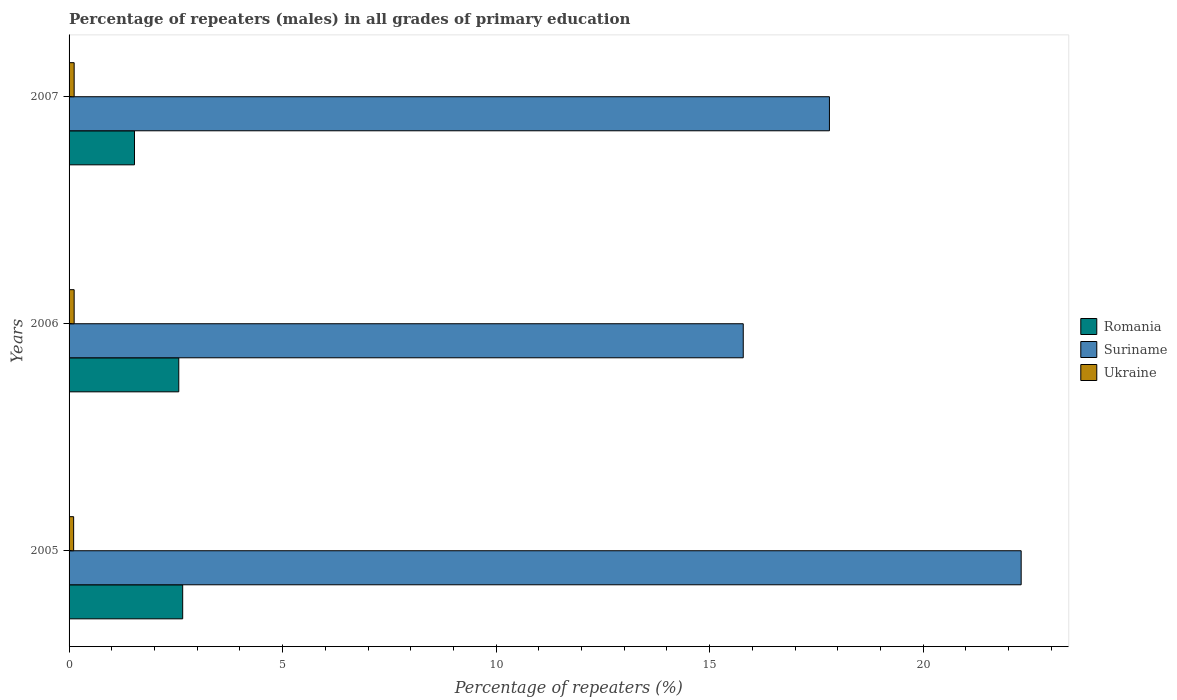How many different coloured bars are there?
Your answer should be very brief. 3. How many groups of bars are there?
Provide a succinct answer. 3. How many bars are there on the 2nd tick from the top?
Offer a terse response. 3. What is the percentage of repeaters (males) in Romania in 2007?
Offer a terse response. 1.53. Across all years, what is the maximum percentage of repeaters (males) in Ukraine?
Give a very brief answer. 0.12. Across all years, what is the minimum percentage of repeaters (males) in Ukraine?
Ensure brevity in your answer.  0.11. In which year was the percentage of repeaters (males) in Romania maximum?
Offer a very short reply. 2005. What is the total percentage of repeaters (males) in Romania in the graph?
Provide a short and direct response. 6.76. What is the difference between the percentage of repeaters (males) in Romania in 2005 and that in 2007?
Ensure brevity in your answer.  1.13. What is the difference between the percentage of repeaters (males) in Romania in 2006 and the percentage of repeaters (males) in Suriname in 2007?
Give a very brief answer. -15.24. What is the average percentage of repeaters (males) in Suriname per year?
Offer a terse response. 18.63. In the year 2005, what is the difference between the percentage of repeaters (males) in Romania and percentage of repeaters (males) in Ukraine?
Your answer should be very brief. 2.55. What is the ratio of the percentage of repeaters (males) in Suriname in 2006 to that in 2007?
Make the answer very short. 0.89. Is the percentage of repeaters (males) in Romania in 2005 less than that in 2006?
Offer a very short reply. No. What is the difference between the highest and the second highest percentage of repeaters (males) in Ukraine?
Keep it short and to the point. 0. What is the difference between the highest and the lowest percentage of repeaters (males) in Ukraine?
Your answer should be very brief. 0.01. In how many years, is the percentage of repeaters (males) in Suriname greater than the average percentage of repeaters (males) in Suriname taken over all years?
Offer a very short reply. 1. Is the sum of the percentage of repeaters (males) in Ukraine in 2005 and 2007 greater than the maximum percentage of repeaters (males) in Suriname across all years?
Keep it short and to the point. No. What does the 2nd bar from the top in 2005 represents?
Your answer should be very brief. Suriname. What does the 1st bar from the bottom in 2005 represents?
Offer a very short reply. Romania. Are all the bars in the graph horizontal?
Your answer should be very brief. Yes. How many years are there in the graph?
Your answer should be very brief. 3. What is the difference between two consecutive major ticks on the X-axis?
Offer a very short reply. 5. Are the values on the major ticks of X-axis written in scientific E-notation?
Offer a very short reply. No. Does the graph contain any zero values?
Your response must be concise. No. Does the graph contain grids?
Your answer should be compact. No. Where does the legend appear in the graph?
Your answer should be compact. Center right. How are the legend labels stacked?
Ensure brevity in your answer.  Vertical. What is the title of the graph?
Give a very brief answer. Percentage of repeaters (males) in all grades of primary education. Does "Grenada" appear as one of the legend labels in the graph?
Your answer should be compact. No. What is the label or title of the X-axis?
Your answer should be very brief. Percentage of repeaters (%). What is the Percentage of repeaters (%) in Romania in 2005?
Offer a terse response. 2.66. What is the Percentage of repeaters (%) of Suriname in 2005?
Make the answer very short. 22.3. What is the Percentage of repeaters (%) in Ukraine in 2005?
Provide a succinct answer. 0.11. What is the Percentage of repeaters (%) in Romania in 2006?
Your response must be concise. 2.57. What is the Percentage of repeaters (%) in Suriname in 2006?
Give a very brief answer. 15.79. What is the Percentage of repeaters (%) in Ukraine in 2006?
Provide a succinct answer. 0.12. What is the Percentage of repeaters (%) in Romania in 2007?
Offer a very short reply. 1.53. What is the Percentage of repeaters (%) in Suriname in 2007?
Provide a succinct answer. 17.81. What is the Percentage of repeaters (%) of Ukraine in 2007?
Make the answer very short. 0.12. Across all years, what is the maximum Percentage of repeaters (%) in Romania?
Offer a terse response. 2.66. Across all years, what is the maximum Percentage of repeaters (%) of Suriname?
Provide a succinct answer. 22.3. Across all years, what is the maximum Percentage of repeaters (%) of Ukraine?
Provide a short and direct response. 0.12. Across all years, what is the minimum Percentage of repeaters (%) in Romania?
Keep it short and to the point. 1.53. Across all years, what is the minimum Percentage of repeaters (%) of Suriname?
Provide a short and direct response. 15.79. Across all years, what is the minimum Percentage of repeaters (%) of Ukraine?
Keep it short and to the point. 0.11. What is the total Percentage of repeaters (%) in Romania in the graph?
Keep it short and to the point. 6.76. What is the total Percentage of repeaters (%) in Suriname in the graph?
Your answer should be very brief. 55.89. What is the total Percentage of repeaters (%) of Ukraine in the graph?
Keep it short and to the point. 0.35. What is the difference between the Percentage of repeaters (%) in Romania in 2005 and that in 2006?
Your response must be concise. 0.09. What is the difference between the Percentage of repeaters (%) in Suriname in 2005 and that in 2006?
Provide a short and direct response. 6.51. What is the difference between the Percentage of repeaters (%) in Ukraine in 2005 and that in 2006?
Provide a short and direct response. -0.01. What is the difference between the Percentage of repeaters (%) of Romania in 2005 and that in 2007?
Give a very brief answer. 1.13. What is the difference between the Percentage of repeaters (%) of Suriname in 2005 and that in 2007?
Provide a short and direct response. 4.49. What is the difference between the Percentage of repeaters (%) of Ukraine in 2005 and that in 2007?
Make the answer very short. -0.01. What is the difference between the Percentage of repeaters (%) in Romania in 2006 and that in 2007?
Provide a succinct answer. 1.04. What is the difference between the Percentage of repeaters (%) in Suriname in 2006 and that in 2007?
Provide a succinct answer. -2.02. What is the difference between the Percentage of repeaters (%) of Ukraine in 2006 and that in 2007?
Offer a terse response. -0. What is the difference between the Percentage of repeaters (%) of Romania in 2005 and the Percentage of repeaters (%) of Suriname in 2006?
Ensure brevity in your answer.  -13.13. What is the difference between the Percentage of repeaters (%) in Romania in 2005 and the Percentage of repeaters (%) in Ukraine in 2006?
Your answer should be compact. 2.54. What is the difference between the Percentage of repeaters (%) in Suriname in 2005 and the Percentage of repeaters (%) in Ukraine in 2006?
Offer a terse response. 22.18. What is the difference between the Percentage of repeaters (%) of Romania in 2005 and the Percentage of repeaters (%) of Suriname in 2007?
Give a very brief answer. -15.15. What is the difference between the Percentage of repeaters (%) of Romania in 2005 and the Percentage of repeaters (%) of Ukraine in 2007?
Ensure brevity in your answer.  2.54. What is the difference between the Percentage of repeaters (%) of Suriname in 2005 and the Percentage of repeaters (%) of Ukraine in 2007?
Make the answer very short. 22.18. What is the difference between the Percentage of repeaters (%) in Romania in 2006 and the Percentage of repeaters (%) in Suriname in 2007?
Make the answer very short. -15.24. What is the difference between the Percentage of repeaters (%) of Romania in 2006 and the Percentage of repeaters (%) of Ukraine in 2007?
Offer a terse response. 2.45. What is the difference between the Percentage of repeaters (%) in Suriname in 2006 and the Percentage of repeaters (%) in Ukraine in 2007?
Your response must be concise. 15.67. What is the average Percentage of repeaters (%) of Romania per year?
Keep it short and to the point. 2.25. What is the average Percentage of repeaters (%) of Suriname per year?
Offer a terse response. 18.63. What is the average Percentage of repeaters (%) in Ukraine per year?
Provide a succinct answer. 0.12. In the year 2005, what is the difference between the Percentage of repeaters (%) in Romania and Percentage of repeaters (%) in Suriname?
Provide a short and direct response. -19.63. In the year 2005, what is the difference between the Percentage of repeaters (%) of Romania and Percentage of repeaters (%) of Ukraine?
Offer a terse response. 2.55. In the year 2005, what is the difference between the Percentage of repeaters (%) in Suriname and Percentage of repeaters (%) in Ukraine?
Your answer should be very brief. 22.19. In the year 2006, what is the difference between the Percentage of repeaters (%) in Romania and Percentage of repeaters (%) in Suriname?
Your answer should be compact. -13.22. In the year 2006, what is the difference between the Percentage of repeaters (%) in Romania and Percentage of repeaters (%) in Ukraine?
Ensure brevity in your answer.  2.45. In the year 2006, what is the difference between the Percentage of repeaters (%) in Suriname and Percentage of repeaters (%) in Ukraine?
Your response must be concise. 15.67. In the year 2007, what is the difference between the Percentage of repeaters (%) of Romania and Percentage of repeaters (%) of Suriname?
Your answer should be compact. -16.27. In the year 2007, what is the difference between the Percentage of repeaters (%) of Romania and Percentage of repeaters (%) of Ukraine?
Offer a terse response. 1.41. In the year 2007, what is the difference between the Percentage of repeaters (%) in Suriname and Percentage of repeaters (%) in Ukraine?
Provide a succinct answer. 17.69. What is the ratio of the Percentage of repeaters (%) in Romania in 2005 to that in 2006?
Keep it short and to the point. 1.04. What is the ratio of the Percentage of repeaters (%) in Suriname in 2005 to that in 2006?
Keep it short and to the point. 1.41. What is the ratio of the Percentage of repeaters (%) in Ukraine in 2005 to that in 2006?
Ensure brevity in your answer.  0.9. What is the ratio of the Percentage of repeaters (%) in Romania in 2005 to that in 2007?
Your answer should be compact. 1.74. What is the ratio of the Percentage of repeaters (%) of Suriname in 2005 to that in 2007?
Your answer should be very brief. 1.25. What is the ratio of the Percentage of repeaters (%) in Ukraine in 2005 to that in 2007?
Ensure brevity in your answer.  0.9. What is the ratio of the Percentage of repeaters (%) of Romania in 2006 to that in 2007?
Keep it short and to the point. 1.68. What is the ratio of the Percentage of repeaters (%) of Suriname in 2006 to that in 2007?
Offer a very short reply. 0.89. What is the ratio of the Percentage of repeaters (%) in Ukraine in 2006 to that in 2007?
Ensure brevity in your answer.  1. What is the difference between the highest and the second highest Percentage of repeaters (%) of Romania?
Provide a succinct answer. 0.09. What is the difference between the highest and the second highest Percentage of repeaters (%) of Suriname?
Offer a very short reply. 4.49. What is the difference between the highest and the lowest Percentage of repeaters (%) of Romania?
Keep it short and to the point. 1.13. What is the difference between the highest and the lowest Percentage of repeaters (%) in Suriname?
Your answer should be compact. 6.51. What is the difference between the highest and the lowest Percentage of repeaters (%) in Ukraine?
Give a very brief answer. 0.01. 